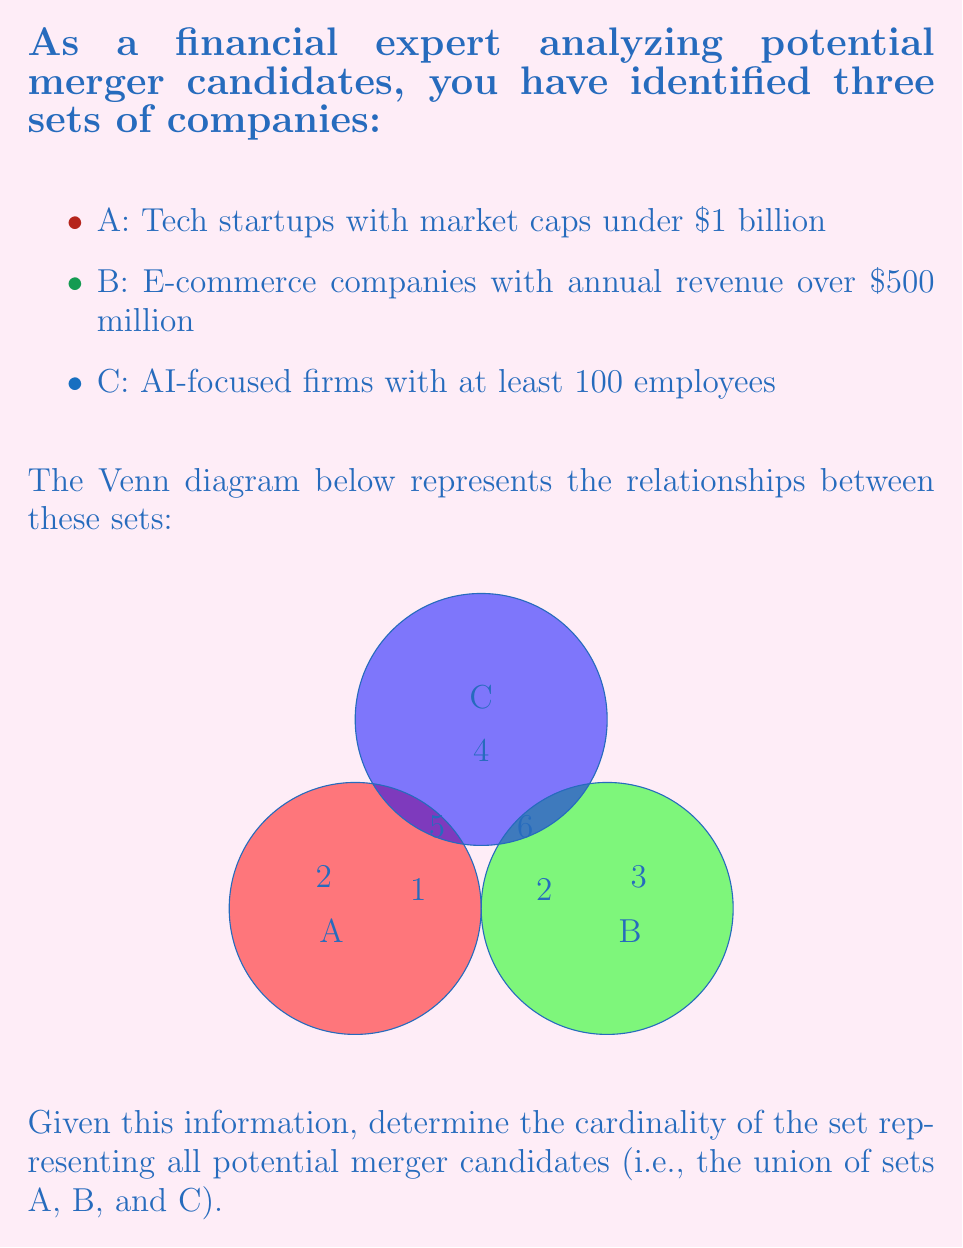Solve this math problem. To find the cardinality of the union of sets A, B, and C, we'll use the Inclusion-Exclusion Principle:

$$|A \cup B \cup C| = |A| + |B| + |C| - |A \cap B| - |B \cap C| - |A \cap C| + |A \cap B \cap C|$$

Let's calculate each term:

1. $|A| = 2 + 1 + 5 + 1 = 9$
2. $|B| = 3 + 2 + 5 + 1 = 11$
3. $|C| = 4 + 5 + 6 + 1 = 16$
4. $|A \cap B| = 1$
5. $|B \cap C| = 5$
6. $|A \cap C| = 5$
7. $|A \cap B \cap C| = 1$

Now, let's substitute these values into the formula:

$$|A \cup B \cup C| = 9 + 11 + 16 - 1 - 5 - 5 + 1 = 26$$

Therefore, the cardinality of the set representing all potential merger candidates is 26.
Answer: 26 